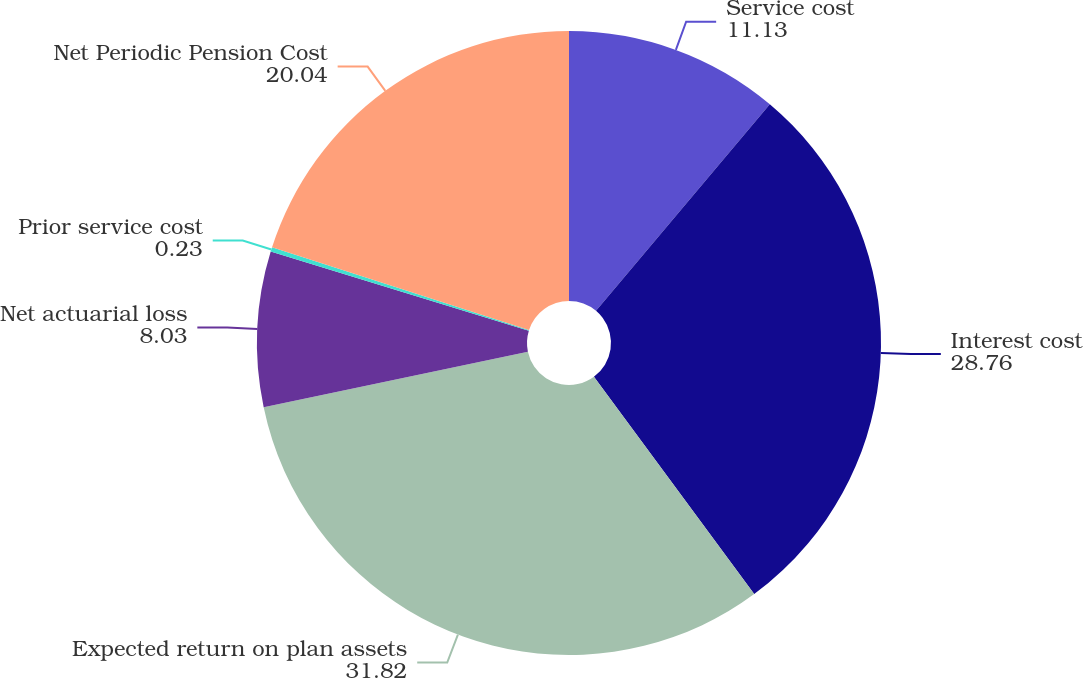Convert chart. <chart><loc_0><loc_0><loc_500><loc_500><pie_chart><fcel>Service cost<fcel>Interest cost<fcel>Expected return on plan assets<fcel>Net actuarial loss<fcel>Prior service cost<fcel>Net Periodic Pension Cost<nl><fcel>11.13%<fcel>28.76%<fcel>31.82%<fcel>8.03%<fcel>0.23%<fcel>20.04%<nl></chart> 